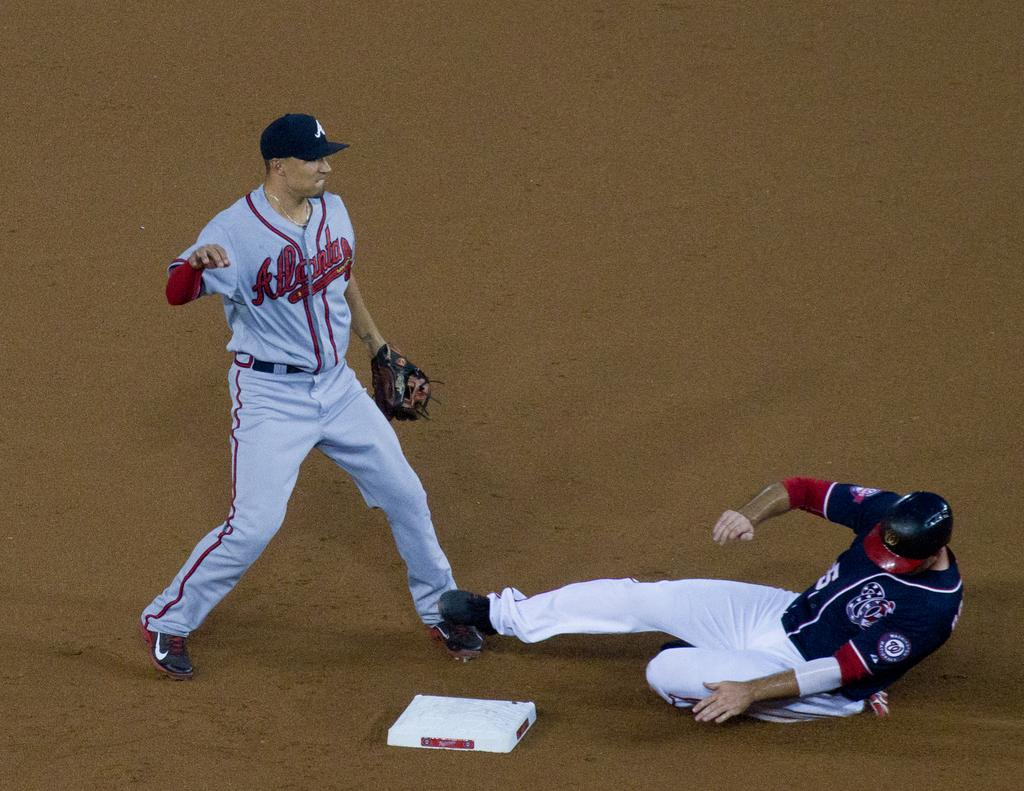Provide a one-sentence caption for the provided image. A player for the Atlanta Braves stands guard at base as a member of the Nationals slides in. 